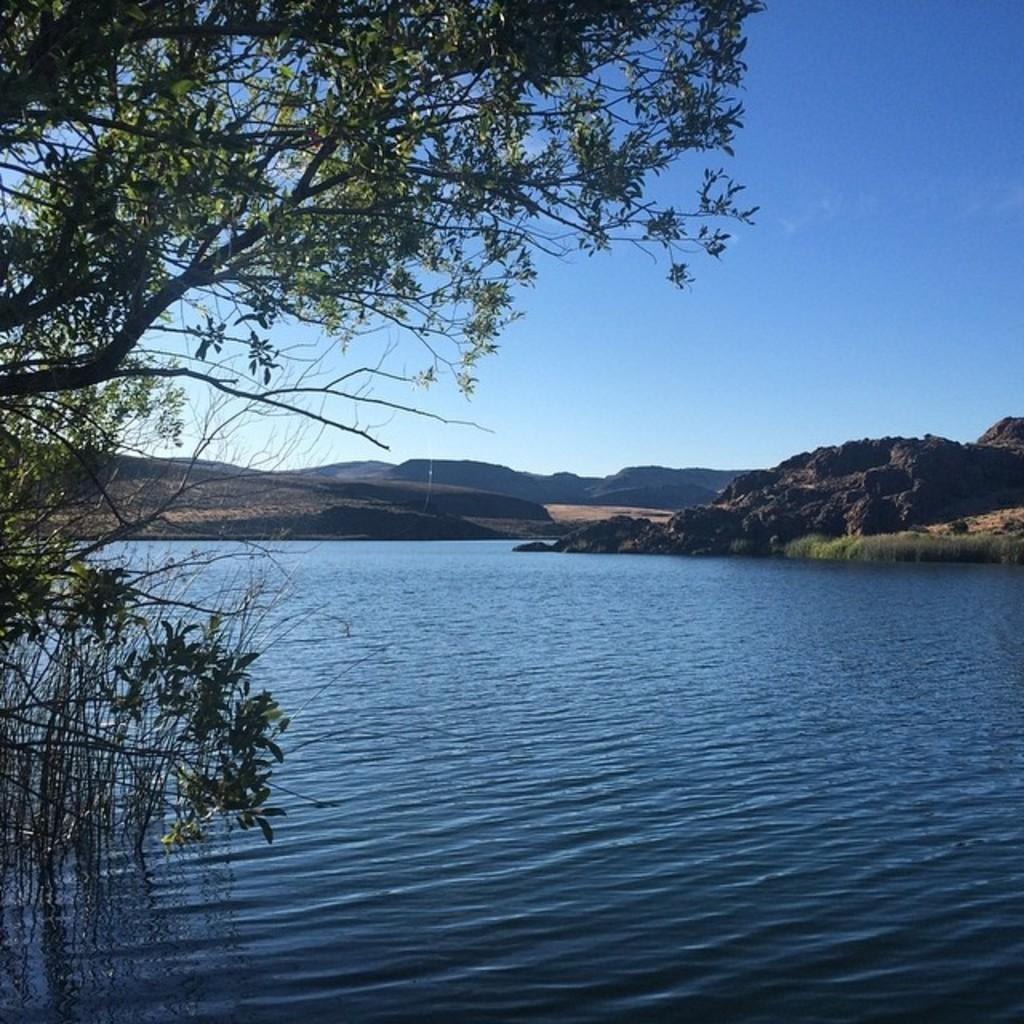What is visible in the image? There is water, a tree, mountains, and the sky visible in the image. Can you describe the tree in the image? The tree is green and black in color. What is the background of the image? The background of the image includes mountains and the sky. How does the maid ensure the comfort of the vacationers in the image? There is no maid or vacationers present in the image; it features water, a tree, mountains, and the sky. 